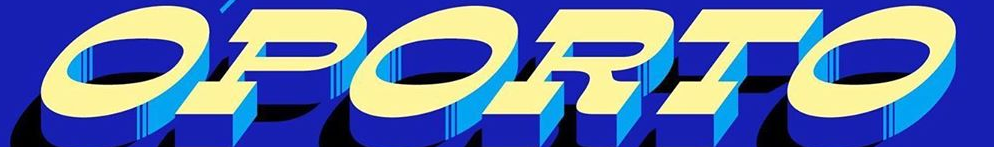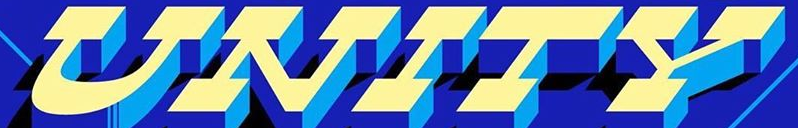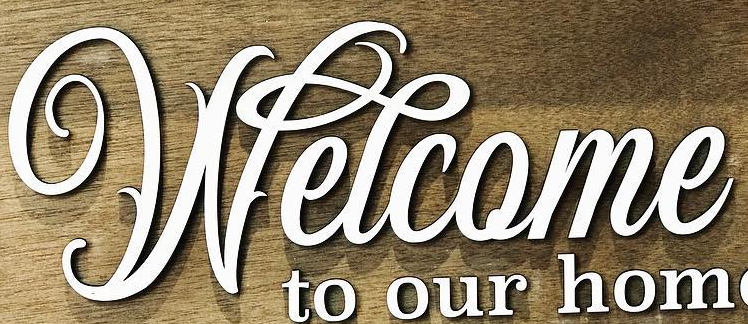Transcribe the words shown in these images in order, separated by a semicolon. OPORTO; UNITY; Welcome 